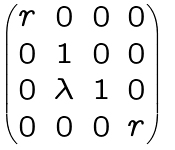Convert formula to latex. <formula><loc_0><loc_0><loc_500><loc_500>\begin{pmatrix} r & 0 & 0 & 0 \\ 0 & 1 & 0 & 0 \\ 0 & \lambda & 1 & 0 \\ 0 & 0 & 0 & r \end{pmatrix}</formula> 